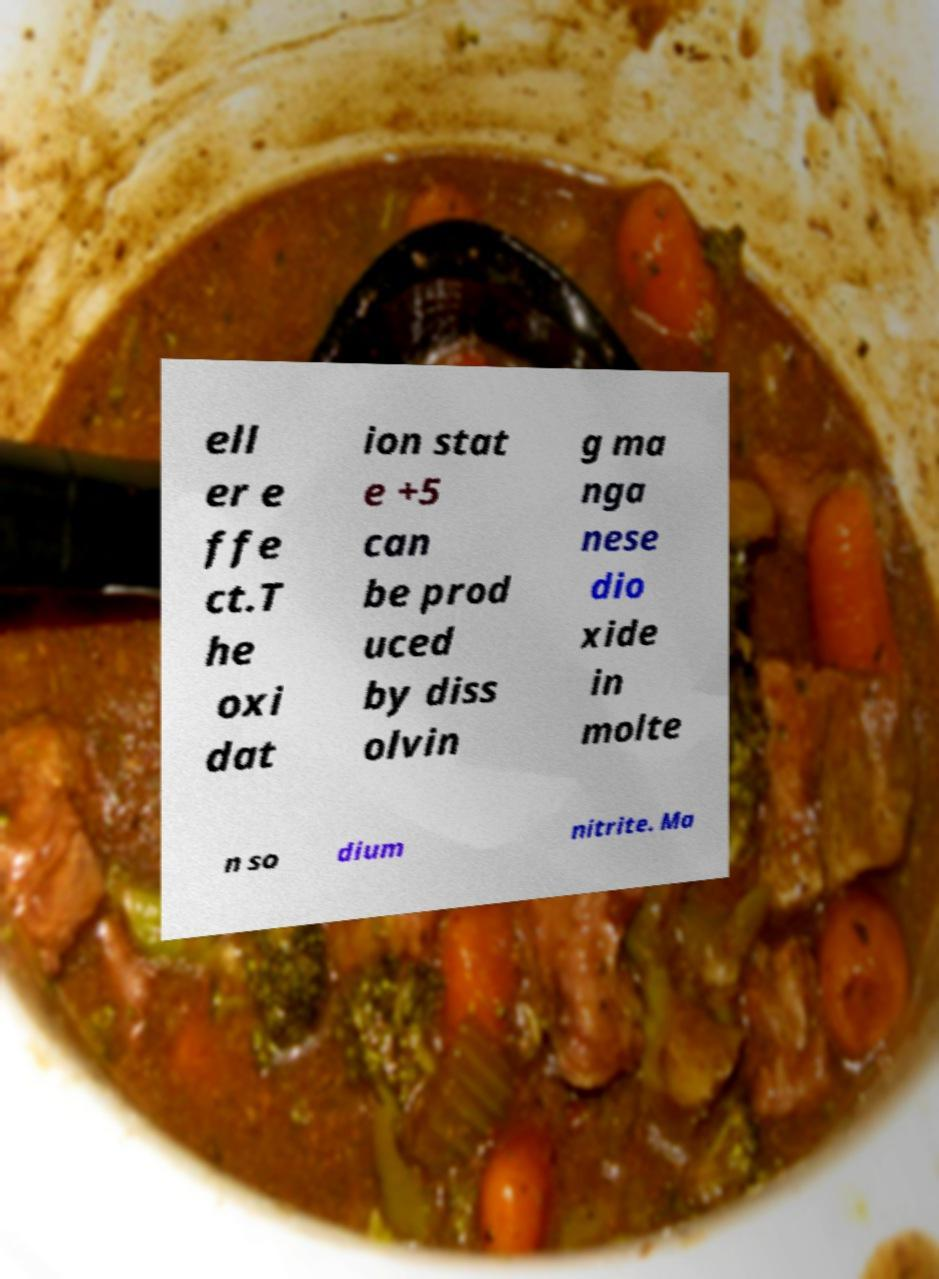Can you read and provide the text displayed in the image?This photo seems to have some interesting text. Can you extract and type it out for me? ell er e ffe ct.T he oxi dat ion stat e +5 can be prod uced by diss olvin g ma nga nese dio xide in molte n so dium nitrite. Ma 